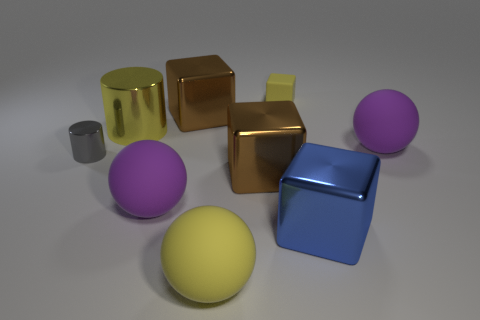Subtract all cubes. How many objects are left? 5 Subtract all tiny yellow matte blocks. Subtract all large shiny blocks. How many objects are left? 5 Add 4 purple matte objects. How many purple matte objects are left? 6 Add 8 yellow shiny objects. How many yellow shiny objects exist? 9 Subtract 0 cyan cylinders. How many objects are left? 9 